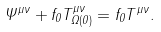Convert formula to latex. <formula><loc_0><loc_0><loc_500><loc_500>\Psi ^ { \mu \nu } + f _ { 0 } T _ { \Omega ( 0 ) } ^ { \mu \nu } = f _ { 0 } T ^ { \mu \nu } .</formula> 